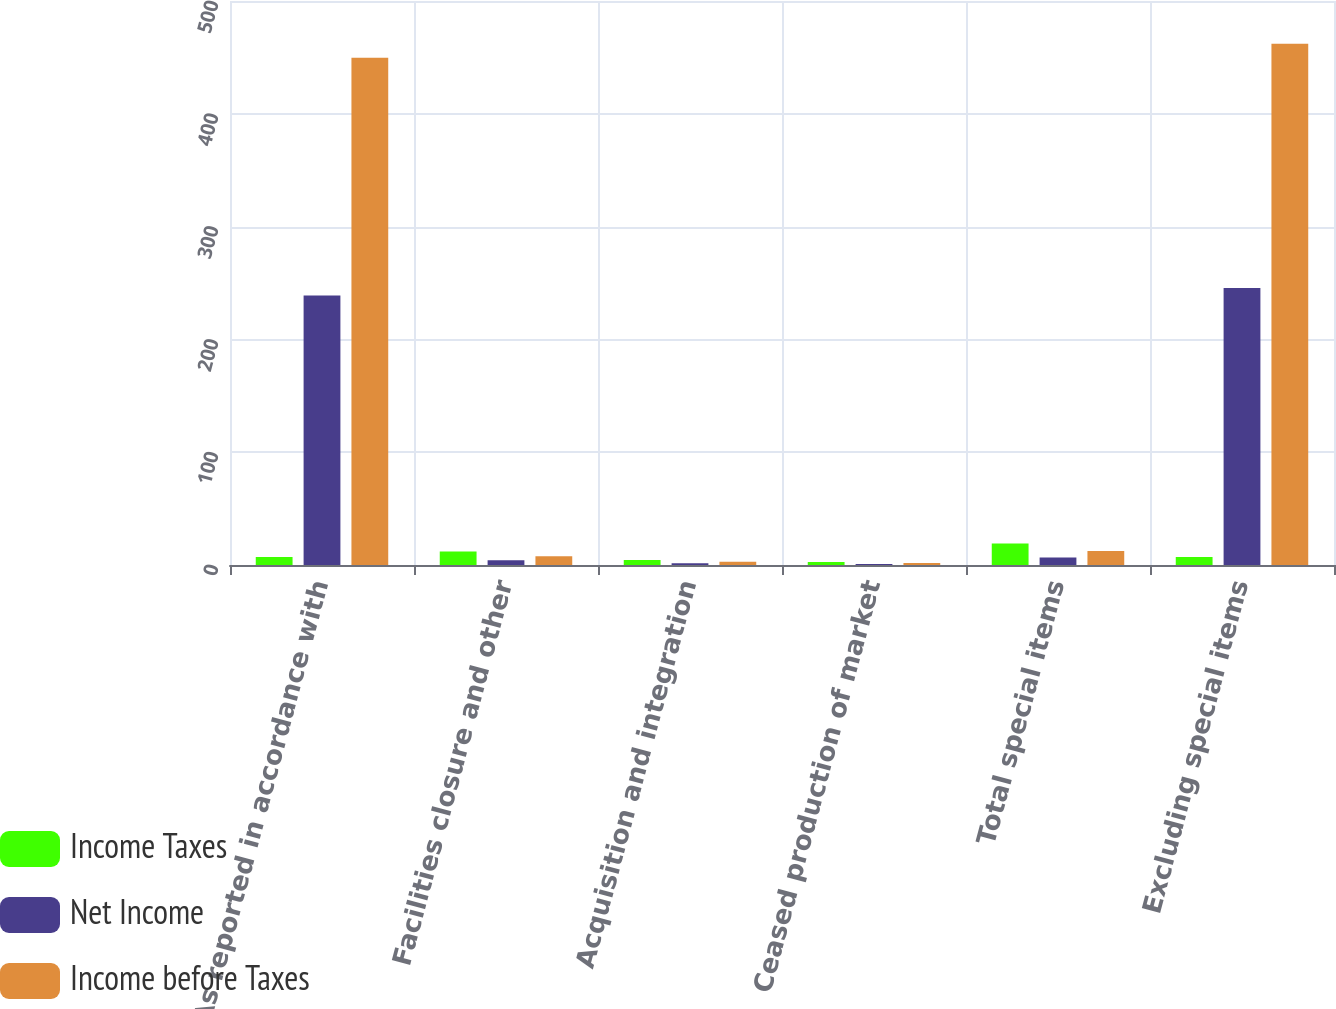<chart> <loc_0><loc_0><loc_500><loc_500><stacked_bar_chart><ecel><fcel>As reported in accordance with<fcel>Facilities closure and other<fcel>Acquisition and integration<fcel>Ceased production of market<fcel>Total special items<fcel>Excluding special items<nl><fcel>Income Taxes<fcel>7.2<fcel>11.9<fcel>4.5<fcel>2.7<fcel>19.1<fcel>7.2<nl><fcel>Net Income<fcel>238.9<fcel>4.2<fcel>1.6<fcel>0.9<fcel>6.7<fcel>245.6<nl><fcel>Income before Taxes<fcel>449.6<fcel>7.7<fcel>2.9<fcel>1.8<fcel>12.4<fcel>462<nl></chart> 